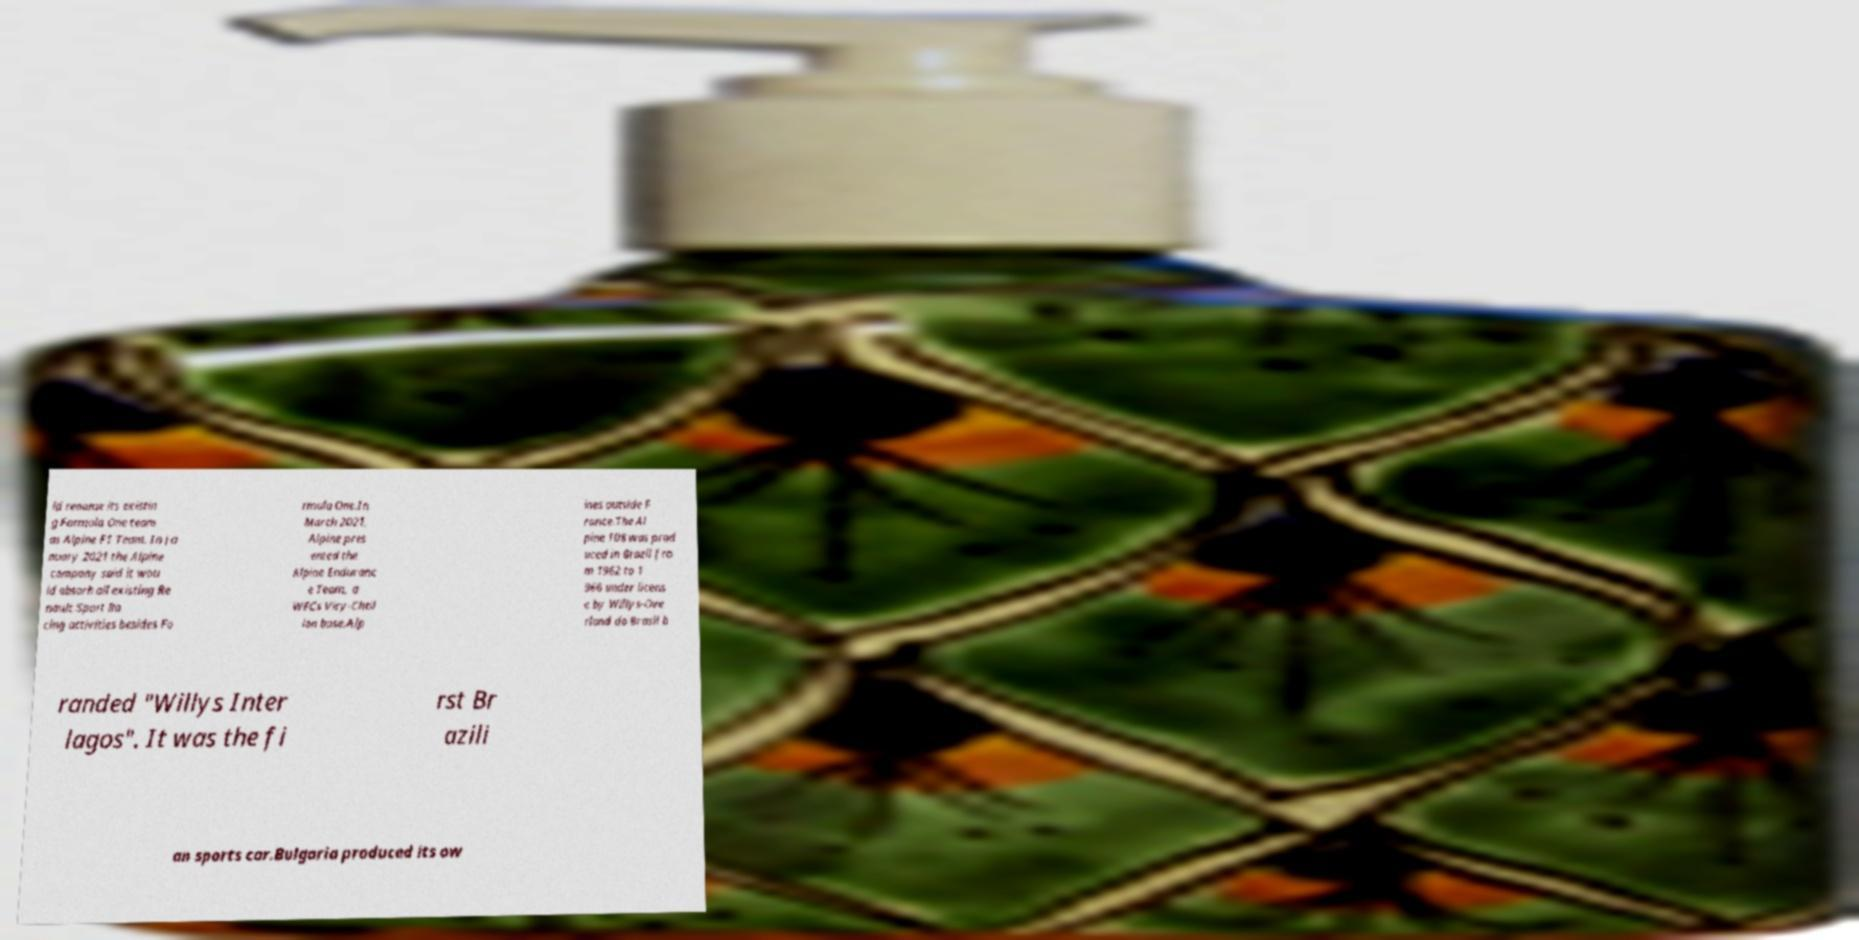Can you accurately transcribe the text from the provided image for me? ld rename its existin g Formula One team as Alpine F1 Team. In Ja nuary 2021 the Alpine company said it wou ld absorb all existing Re nault Sport Ra cing activities besides Fo rmula One.In March 2021, Alpine pres ented the Alpine Enduranc e Team, a WECs Viry-Chtil lon base.Alp ines outside F rance.The Al pine 108 was prod uced in Brazil fro m 1962 to 1 966 under licens e by Willys-Ove rland do Brasil b randed "Willys Inter lagos". It was the fi rst Br azili an sports car.Bulgaria produced its ow 